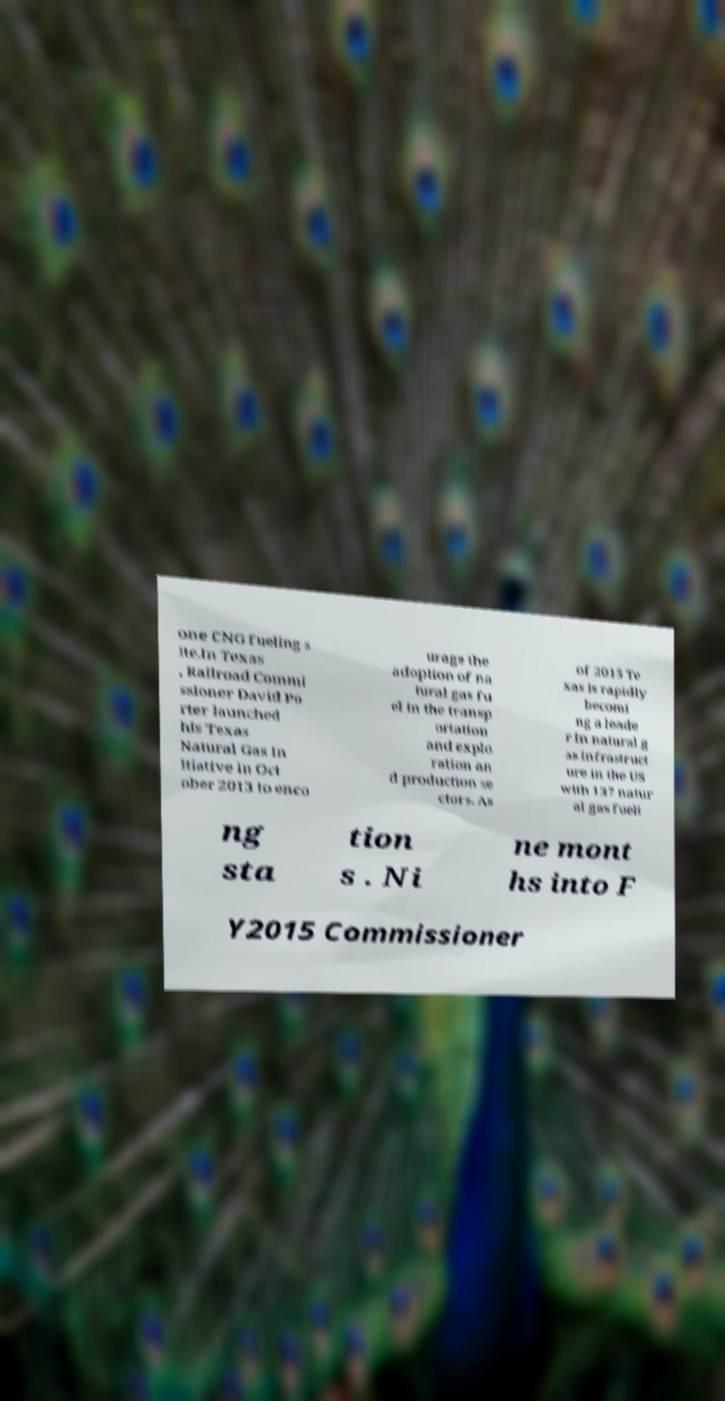Please identify and transcribe the text found in this image. one CNG fueling s ite.In Texas , Railroad Commi ssioner David Po rter launched his Texas Natural Gas In itiative in Oct ober 2013 to enco urage the adoption of na tural gas fu el in the transp ortation and explo ration an d production se ctors. As of 2015 Te xas is rapidly becomi ng a leade r in natural g as infrastruct ure in the US with 137 natur al gas fueli ng sta tion s . Ni ne mont hs into F Y2015 Commissioner 